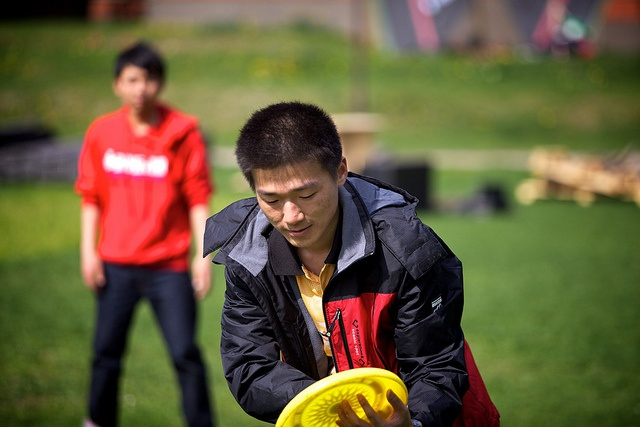Describe the objects in this image and their specific colors. I can see people in black, gray, and maroon tones, people in black, salmon, red, and maroon tones, and frisbee in black, gold, olive, and khaki tones in this image. 